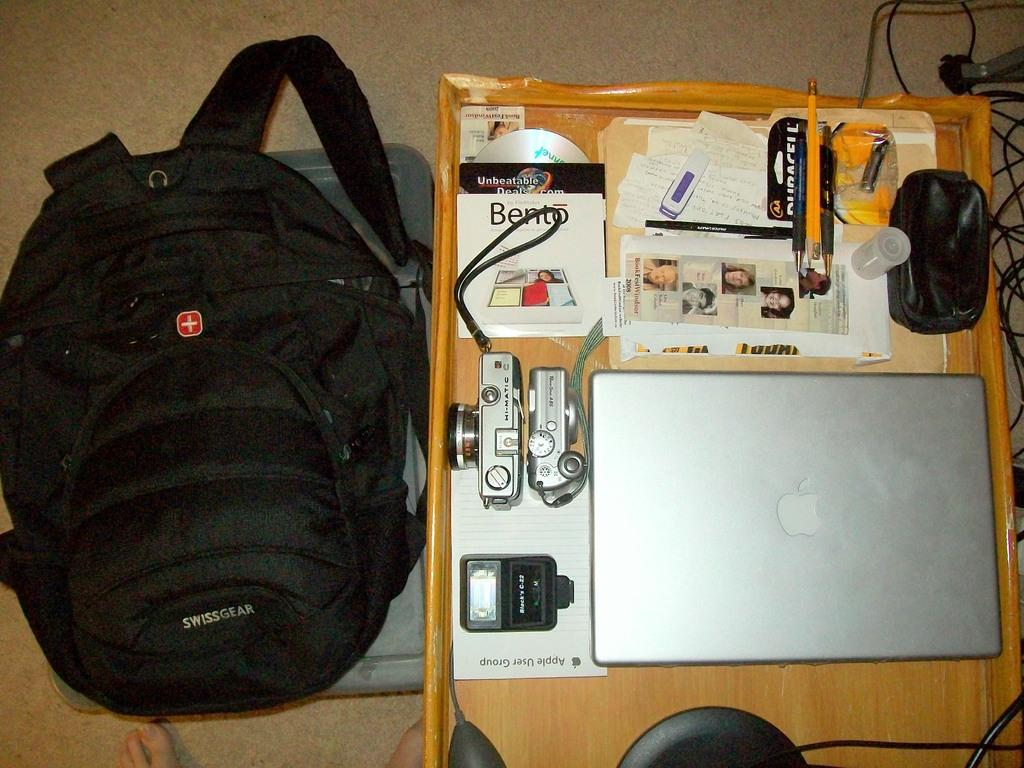<image>
Share a concise interpretation of the image provided. a computer that has an apple logo on it 